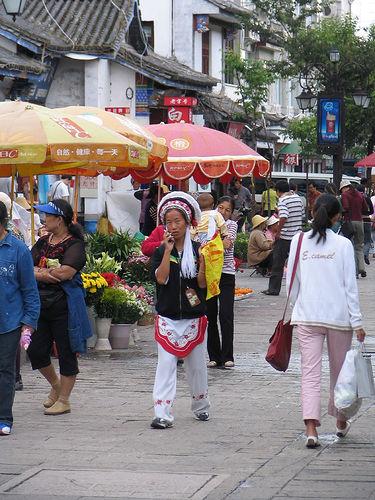What color do you see a lot of?
Give a very brief answer. White. Does this appear to be an outdoor market?
Keep it brief. Yes. Is the writing on the signs in English?
Answer briefly. No. 